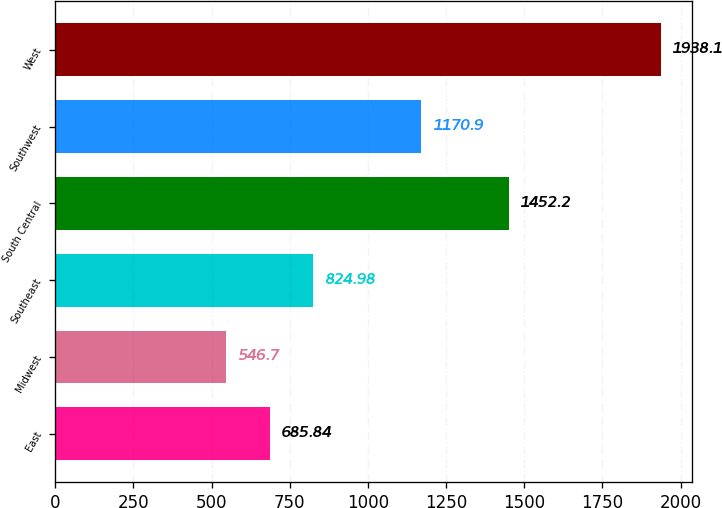Convert chart. <chart><loc_0><loc_0><loc_500><loc_500><bar_chart><fcel>East<fcel>Midwest<fcel>Southeast<fcel>South Central<fcel>Southwest<fcel>West<nl><fcel>685.84<fcel>546.7<fcel>824.98<fcel>1452.2<fcel>1170.9<fcel>1938.1<nl></chart> 